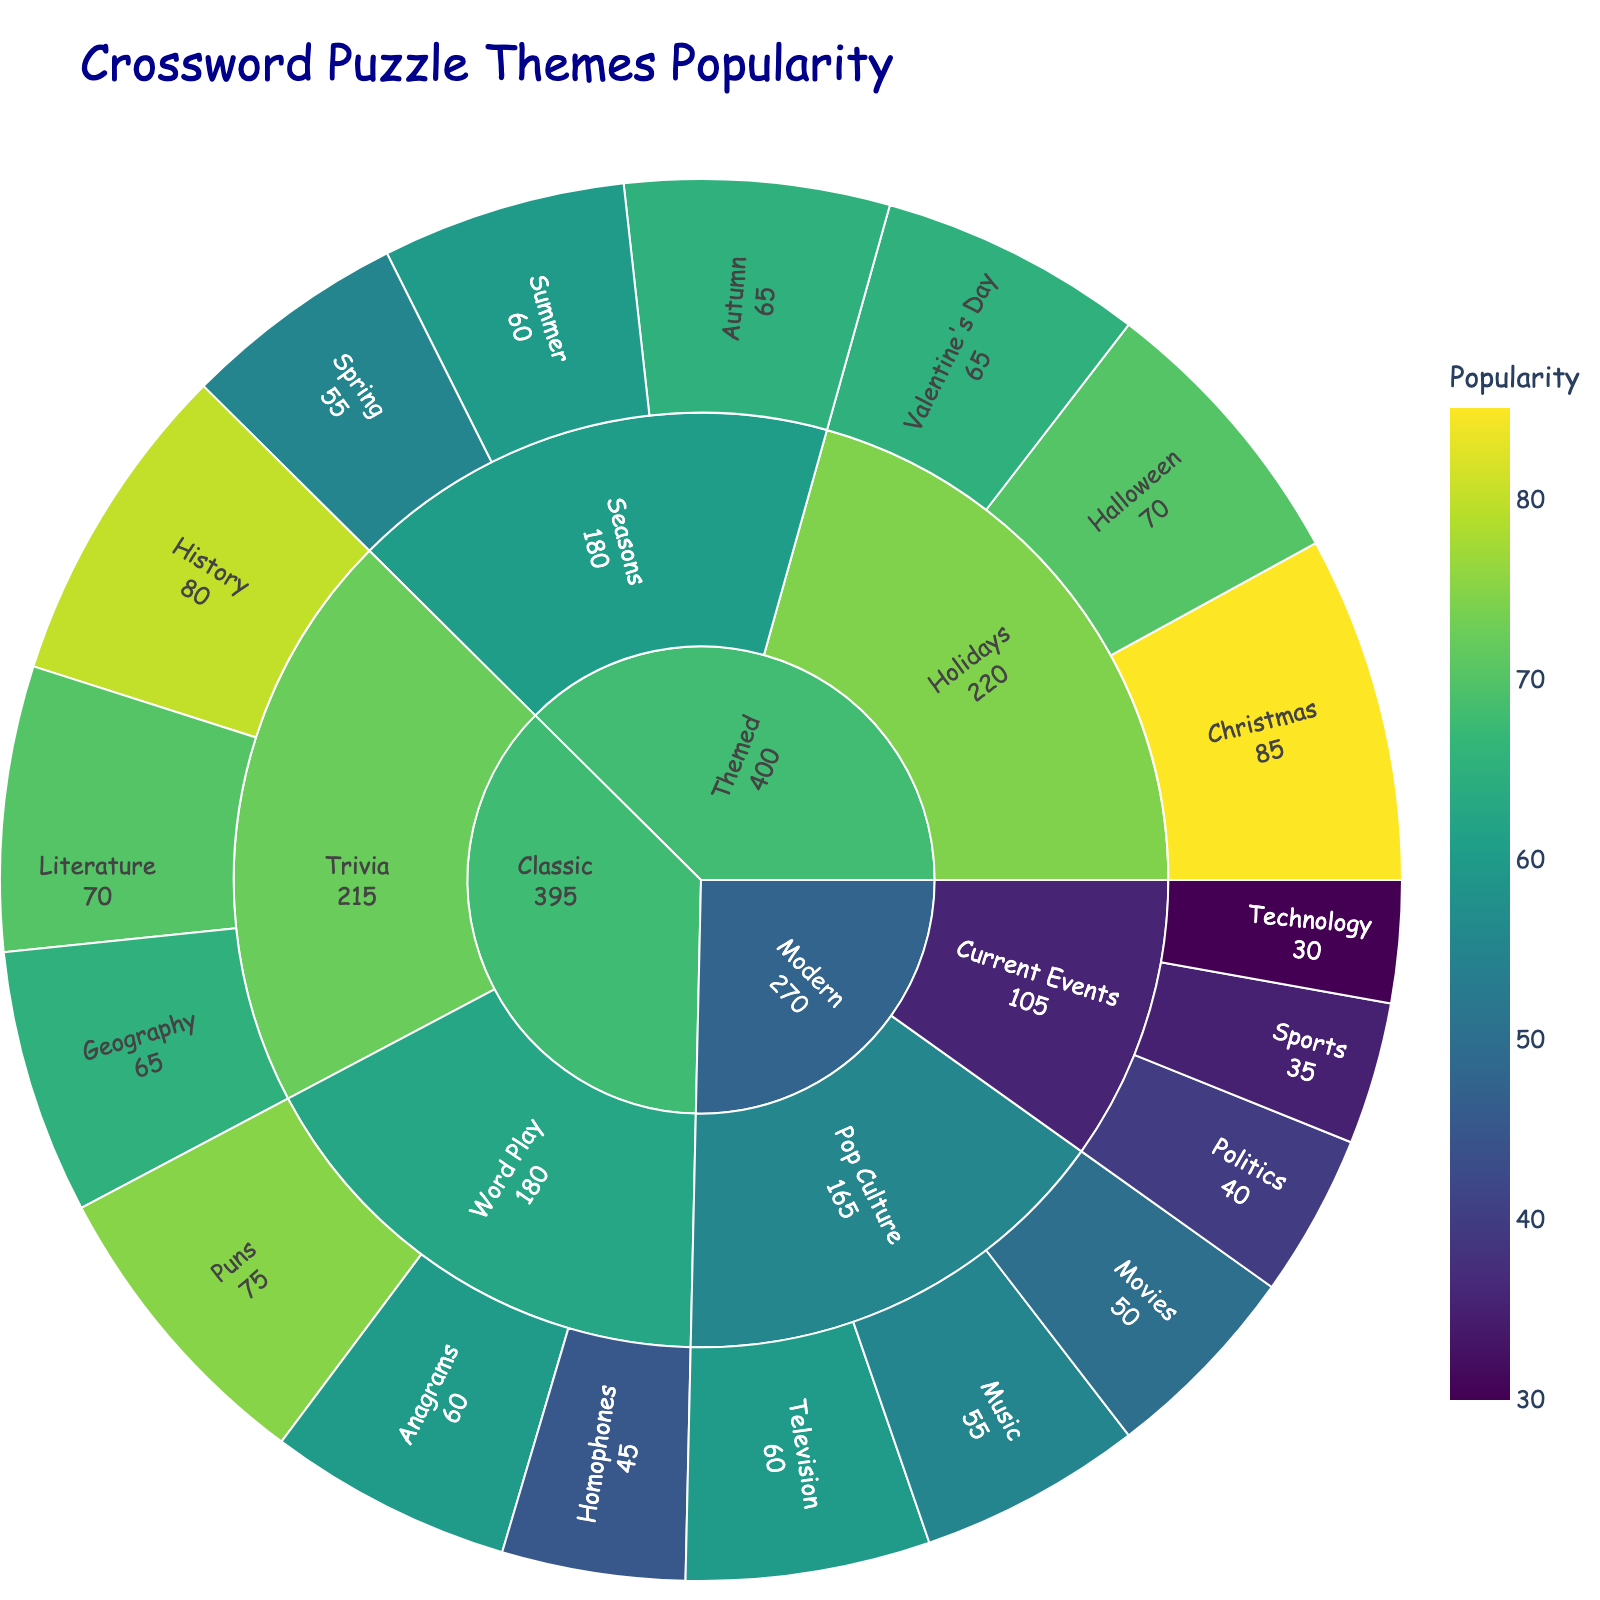What is the title of the Sunburst Plot? The Sunburst Plot displays the title prominently at the top of the chart. The title should be directly readable from there.
Answer: Crossword Puzzle Themes Popularity Which theme in the "Modern" category under "Current Events" has the highest popularity? To find this, look at the "Modern" category, and then the "Current Events" subcategory. Compare the popularity values for "Politics," "Sports," and "Technology." The one with the highest value is the answer.
Answer: Politics In the "Classic" category, which subcategory has the highest total popularity? Sum the popularity values for both subcategories under "Classic": Word Play (75 + 60 + 45 = 180) and Trivia (80 + 65 + 70 = 215). The subcategory with the higher total is the answer.
Answer: Trivia Which theme has the lowest popularity overall? Look at all the themes and their popularity values. Identify the theme with the smallest value.
Answer: Technology What is the total popularity for the "Themed" category? Sum the popularity values for all themes under the "Themed" category: Christmas (85), Halloween (70), Valentine’s Day (65), Spring (55), Summer (60), Autumn (65). 85 + 70 + 65 + 55 + 60 + 65 = 400.
Answer: 400 How does the popularity of "Christmas" compare to "Movies"? Look at the "Themed" category under "Holidays" for "Christmas" and the "Modern" category under "Pop Culture" for "Movies". Compare their popularity values.
Answer: Christmas is more popular Which subcategory has more themes: "Pop Culture" or "Seasons"? Count the number of themes in each subcategory. "Pop Culture" (Movies, Music, Television: 3 themes), and "Seasons" (Spring, Summer, Autumn: 3 themes). Both have an equal number of themes.
Answer: They have the same number of themes What is the average popularity of themes under the "Word Play" subcategory? Sum the popularity values for themes under "Word Play" (Puns 75, Anagrams 60, Homophones 45) and then divide by the number of themes. (75 + 60 + 45) / 3 = 60.
Answer: 60 Which category has the smallest total popularity? Sum the popularity values for themes under each category: Classic (395), Modern (295), Themed (400). Compare the sums to find the smallest.
Answer: Modern What percentage of the "Classic" category's total popularity comes from the "Trivia" subcategory? Calculate the total popularity of "Classic" (395). The popularity of "Trivia" is 215. Divide 215 by 395 and multiply by 100 to get the percentage. (215/395) * 100 ≈ 54.43%.
Answer: 54.43% 